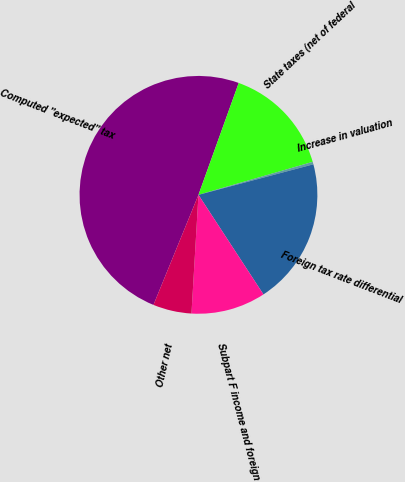Convert chart to OTSL. <chart><loc_0><loc_0><loc_500><loc_500><pie_chart><fcel>Computed ''expected'' tax<fcel>State taxes (net of federal<fcel>Increase in valuation<fcel>Foreign tax rate differential<fcel>Subpart F income and foreign<fcel>Other net<nl><fcel>49.32%<fcel>15.03%<fcel>0.34%<fcel>19.93%<fcel>10.14%<fcel>5.24%<nl></chart> 